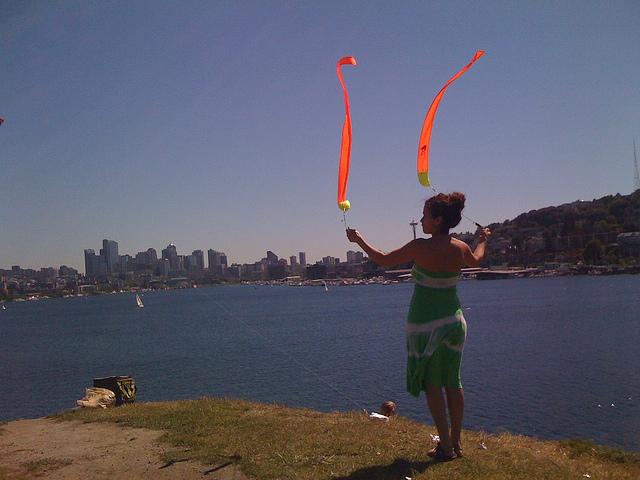Is this lady wearing a dress?
Quick response, please. Yes. What color is the ribbon?
Quick response, please. Orange. What is the woman holding?
Keep it brief. Flags. How many waves are in the water?
Quick response, please. 0. What is the orange thing on the men?
Concise answer only. Kites. Is the woman doing a dance with the kite?
Write a very short answer. Yes. Is it sunny?
Be succinct. Yes. What style shirt is she wearing?
Give a very brief answer. Dress. What is in the sky?
Give a very brief answer. Nothing. What is the waterway for?
Keep it brief. Boats. What is the weather like?
Keep it brief. Sunny. What color is the woman's shoes?
Quick response, please. Brown. Is this a sandy beach?
Concise answer only. No. 